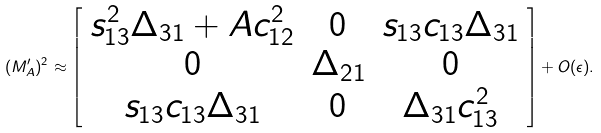Convert formula to latex. <formula><loc_0><loc_0><loc_500><loc_500>( M ^ { \prime } _ { A } ) ^ { 2 } \approx \left [ \begin{array} { c c c } s _ { 1 3 } ^ { 2 } \Delta _ { 3 1 } + A c _ { 1 2 } ^ { 2 } & 0 & s _ { 1 3 } c _ { 1 3 } \Delta _ { 3 1 } \\ 0 & \Delta _ { 2 1 } & 0 \\ s _ { 1 3 } c _ { 1 3 } \Delta _ { 3 1 } & 0 & \Delta _ { 3 1 } c _ { 1 3 } ^ { 2 } \\ \end{array} \right ] + O ( \epsilon ) .</formula> 